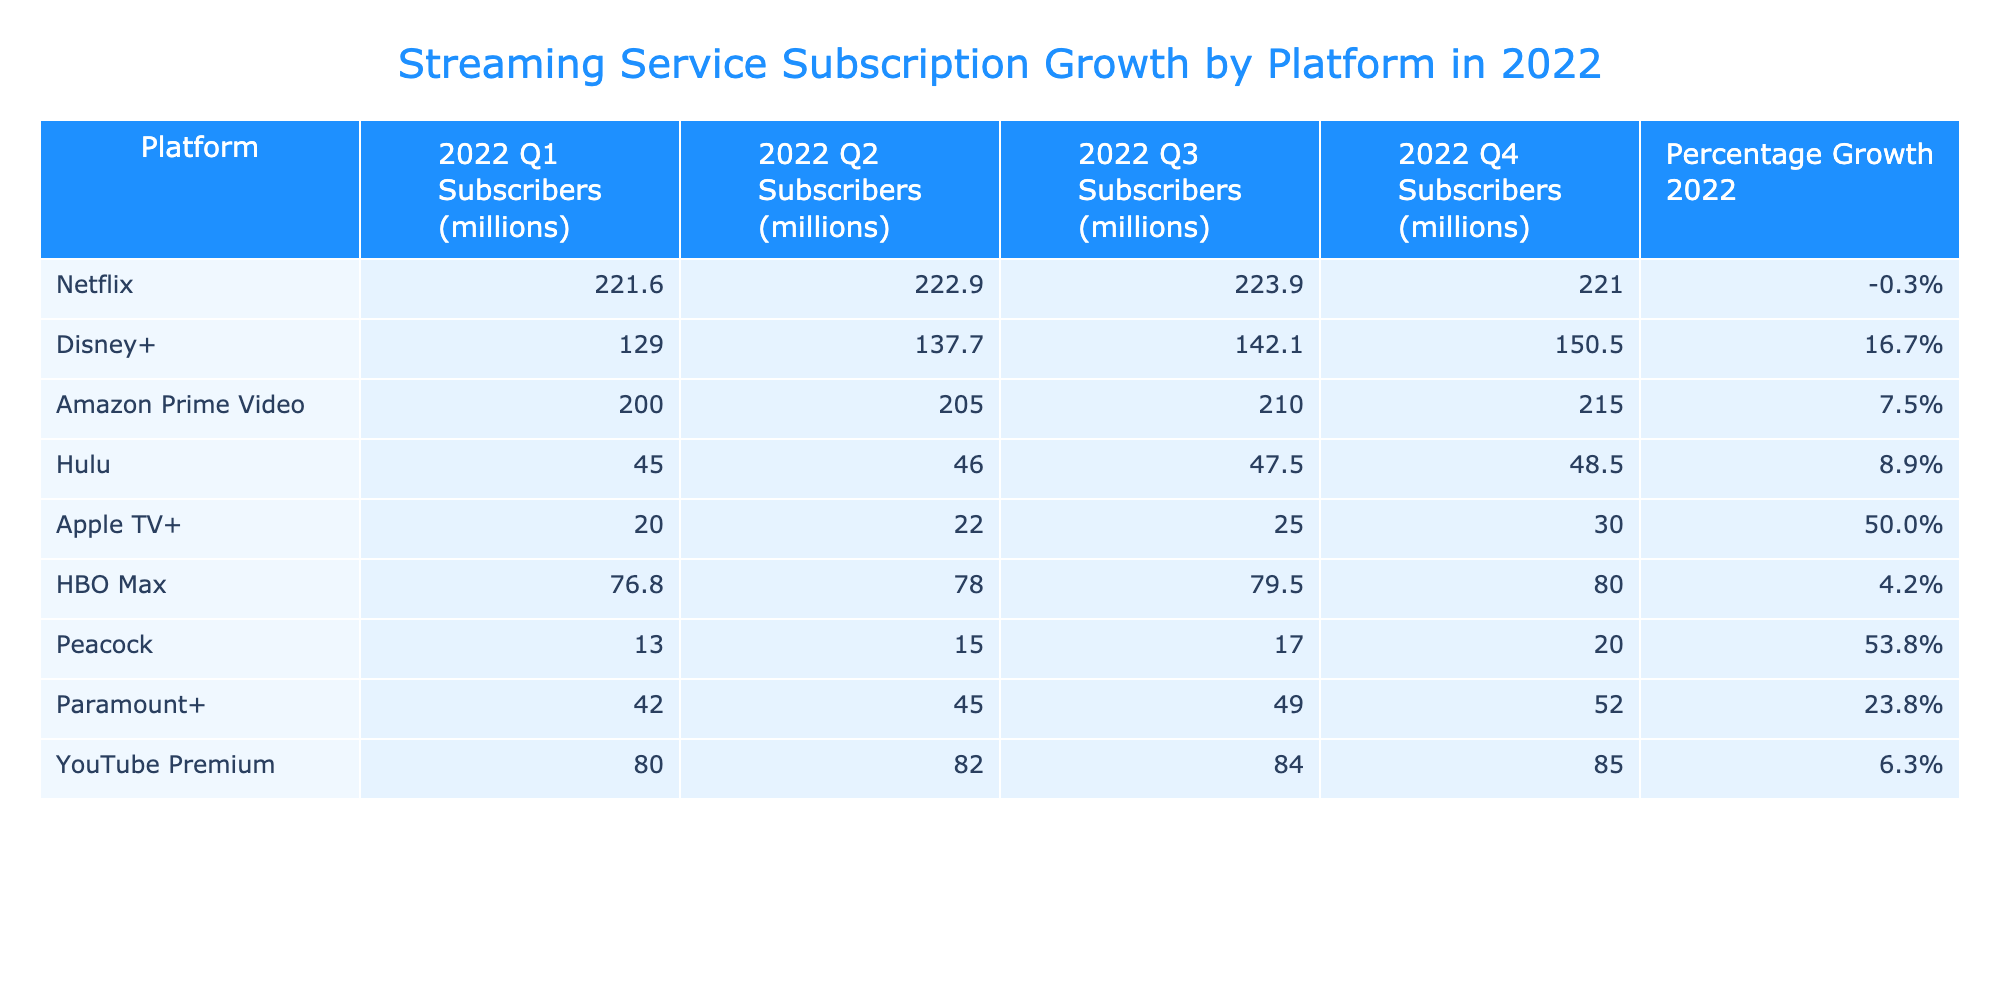What was the subscriber count for Apple TV+ in Q4 2022? According to the table, in Q4 2022, Apple TV+ had 30.0 million subscribers.
Answer: 30.0 million Which platform had the highest percentage growth in 2022? Disney+ recorded the highest percentage growth at 16.7% in 2022, according to the table.
Answer: Disney+ What was the total number of subscribers for Hulu in Q1 and Q2 combined? For Hulu, Q1 had 45.0 million and Q2 had 46.0 million. Adding these figures together gives 45.0 + 46.0 = 91.0 million.
Answer: 91.0 million Did HBO Max experience a decline in subscribers in 2022? HBO Max did not experience a decline; it had a percentage growth of 4.2% in 2022.
Answer: No What is the average number of subscribers across all platforms in Q3 2022? The subscriber counts for Q3 are: 223.9 (Netflix), 142.1 (Disney+), 210.0 (Amazon Prime Video), 47.5 (Hulu), 25.0 (Apple TV+), 79.5 (HBO Max), 17.0 (Peacock), 49.0 (Paramount+), 84.0 (YouTube Premium). Adding these gives 1,579.0 million, and dividing by 9 platforms gives an average of 175.4 million.
Answer: 175.4 million Which platform had more subscribers in Q1 than Q4? Comparing the Q1 and Q4 subscriber counts, only Apple TV+ increased from 20.0 million in Q1 to 30.0 million in Q4, while others either stayed the same or decreased.
Answer: Apple TV+ What was the difference in subscribers between Paramount+ in Q4 and YouTube Premium in Q3? Paramount+ had 52.0 million in Q4 and YouTube Premium had 84.0 million in Q3. The difference is 84.0 - 52.0 = 32.0 million.
Answer: 32.0 million How many platforms had a growth rate above 10% in 2022? Comparing the percentage growth rates, Disney+ (16.7%), Apple TV+ (50.0%), Peacock (53.8%), and Paramount+ (23.8%) had growth rates above 10%. Therefore, there are 4 platforms.
Answer: 4 What was the total subscriber count for Amazon Prime Video throughout the year? The total subscriber count for Amazon Prime Video throughout the year can be calculated by adding the subscribers from all four quarters: 200.0 + 205.0 + 210.0 + 215.0 = 830.0 million.
Answer: 830.0 million Is it true that Netflix lost subscribers in 2022? Yes, Netflix had a total decrease in subscribers from 221.6 million in Q1 to 221.0 million in Q4, which indicates a loss.
Answer: Yes 